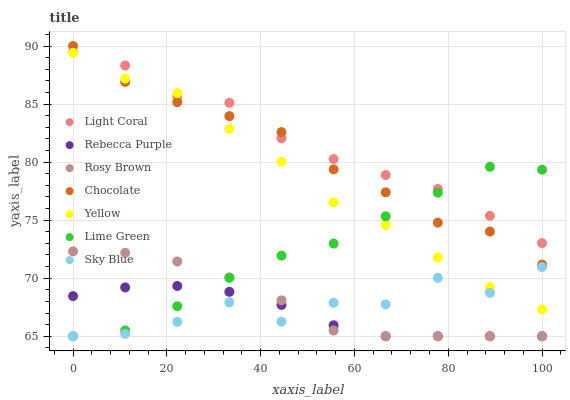Does Rebecca Purple have the minimum area under the curve?
Answer yes or no. Yes. Does Light Coral have the maximum area under the curve?
Answer yes or no. Yes. Does Yellow have the minimum area under the curve?
Answer yes or no. No. Does Yellow have the maximum area under the curve?
Answer yes or no. No. Is Rebecca Purple the smoothest?
Answer yes or no. Yes. Is Sky Blue the roughest?
Answer yes or no. Yes. Is Yellow the smoothest?
Answer yes or no. No. Is Yellow the roughest?
Answer yes or no. No. Does Rosy Brown have the lowest value?
Answer yes or no. Yes. Does Yellow have the lowest value?
Answer yes or no. No. Does Chocolate have the highest value?
Answer yes or no. Yes. Does Yellow have the highest value?
Answer yes or no. No. Is Rosy Brown less than Chocolate?
Answer yes or no. Yes. Is Light Coral greater than Rebecca Purple?
Answer yes or no. Yes. Does Chocolate intersect Yellow?
Answer yes or no. Yes. Is Chocolate less than Yellow?
Answer yes or no. No. Is Chocolate greater than Yellow?
Answer yes or no. No. Does Rosy Brown intersect Chocolate?
Answer yes or no. No. 